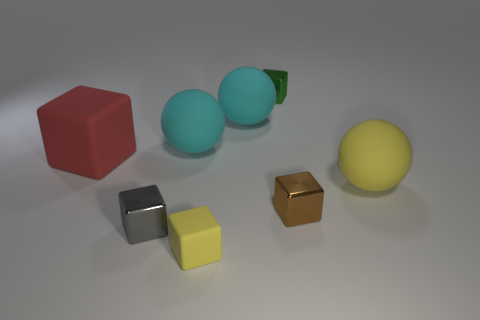Subtract all red blocks. How many blocks are left? 4 Subtract all brown cylinders. How many cyan spheres are left? 2 Add 1 big red objects. How many objects exist? 9 Subtract all yellow blocks. How many blocks are left? 4 Subtract all yellow cubes. Subtract all gray cylinders. How many cubes are left? 4 Subtract all large green rubber balls. Subtract all big cyan balls. How many objects are left? 6 Add 3 spheres. How many spheres are left? 6 Add 4 metallic blocks. How many metallic blocks exist? 7 Subtract 1 yellow spheres. How many objects are left? 7 Subtract all cubes. How many objects are left? 3 